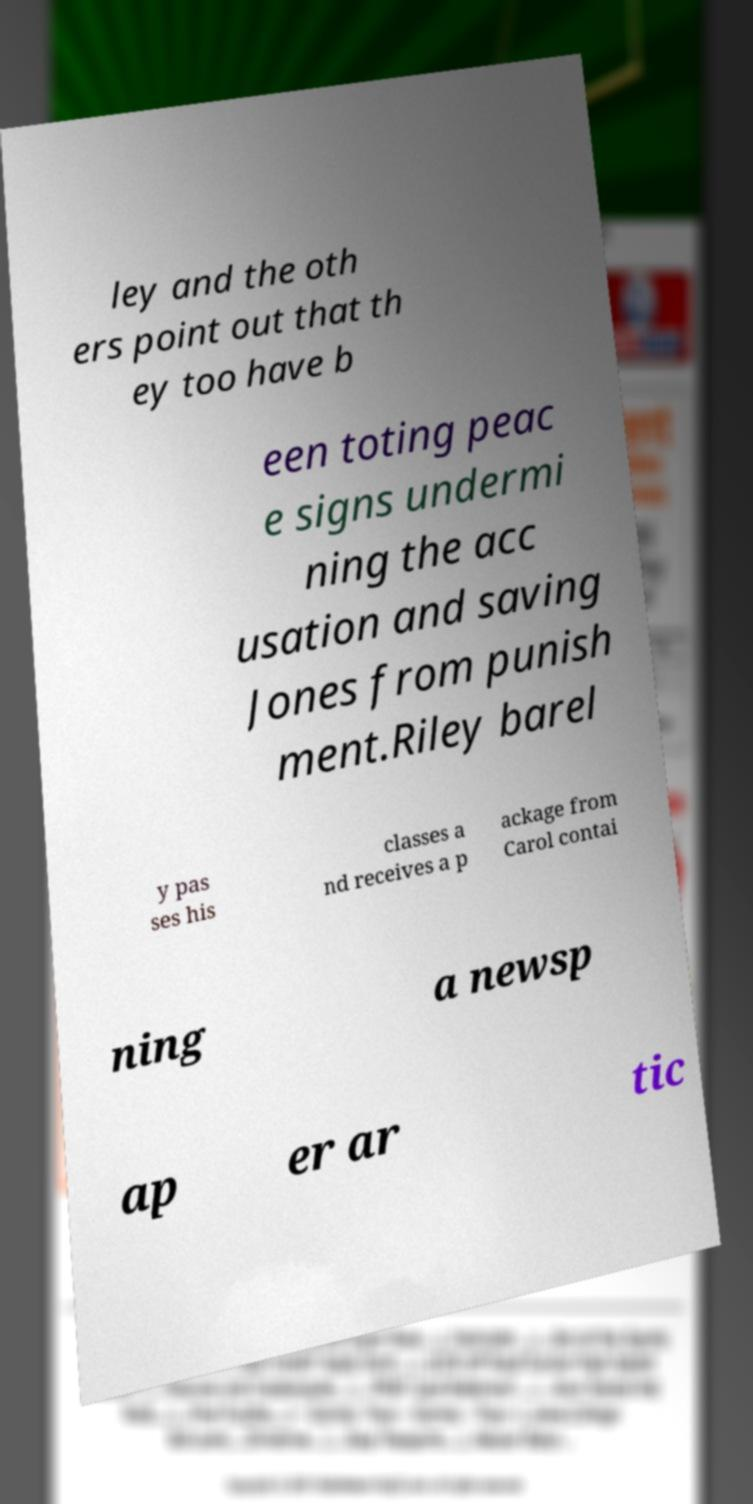Please identify and transcribe the text found in this image. ley and the oth ers point out that th ey too have b een toting peac e signs undermi ning the acc usation and saving Jones from punish ment.Riley barel y pas ses his classes a nd receives a p ackage from Carol contai ning a newsp ap er ar tic 